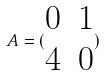<formula> <loc_0><loc_0><loc_500><loc_500>A = ( \begin{matrix} 0 & 1 \\ 4 & 0 \end{matrix} )</formula> 